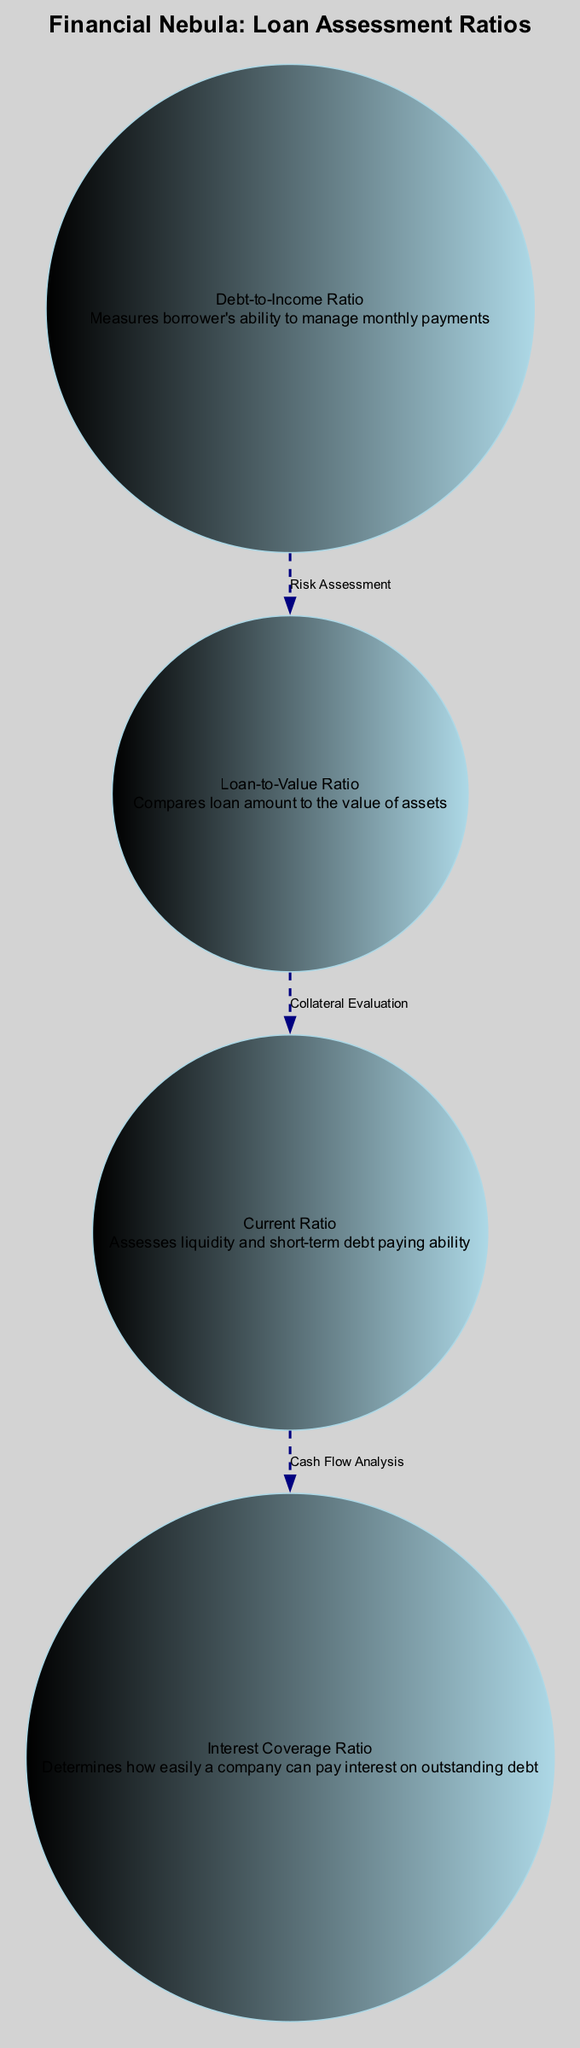What is the outer layer of the nebula labeled as? The outer layer of the nebula is labeled as "Debt-to-Income Ratio," which is explicitly stated in the diagram.
Answer: Debt-to-Income Ratio Which layer comes after the "Loan-to-Value Ratio"? The layer that comes after the "Loan-to-Value Ratio" is the "Current Ratio," as the diagram shows that the "Current Ratio" is placed above the "Loan-to-Value Ratio."
Answer: Current Ratio How many total layers are there in the diagram? The diagram displays a total of four layers, namely the "Debt-to-Income Ratio," "Loan-to-Value Ratio," "Current Ratio," and "Interest Coverage Ratio." Counting these gives us four total layers.
Answer: 4 What does the arrow connecting the "Debt-to-Income Ratio" and "Loan-to-Value Ratio" indicate? The arrow connecting the "Debt-to-Income Ratio" and "Loan-to-Value Ratio" indicates a relationship labeled "Risk Assessment," which suggests that the former affects the latter in the context of financial evaluation.
Answer: Risk Assessment What does the "Interest Coverage Ratio" layer assess? The "Interest Coverage Ratio" layer assesses how easily a company can pay interest on outstanding debt, as described in the diagram.
Answer: Pays interest on outstanding debt What is the nature of the connection between "Current Ratio" and "Interest Coverage Ratio"? The connection between the "Current Ratio" and "Interest Coverage Ratio" is labeled "Cash Flow Analysis," indicating that the liquidity assessed by the "Current Ratio" directly impacts the ability to cover interest payments effectively.
Answer: Cash Flow Analysis Which layer is described as assessing liquidity and short-term debt paying ability? The layer described as assessing liquidity and short-term debt paying ability is the "Current Ratio," which is explicitly stated in the diagram's description of the respective layer.
Answer: Current Ratio What is the position of the "Loan-to-Value Ratio" in the nebula? The position of the "Loan-to-Value Ratio" in the nebula is the middle layer, as indicated by its placement between the outer and inner layers in the diagram.
Answer: Middle Layer Identify the core layer of the nebula. The core layer of the nebula is the "Interest Coverage Ratio," as it is positioned at the central part of the diagram, surrounded by the other layers.
Answer: Interest Coverage Ratio 